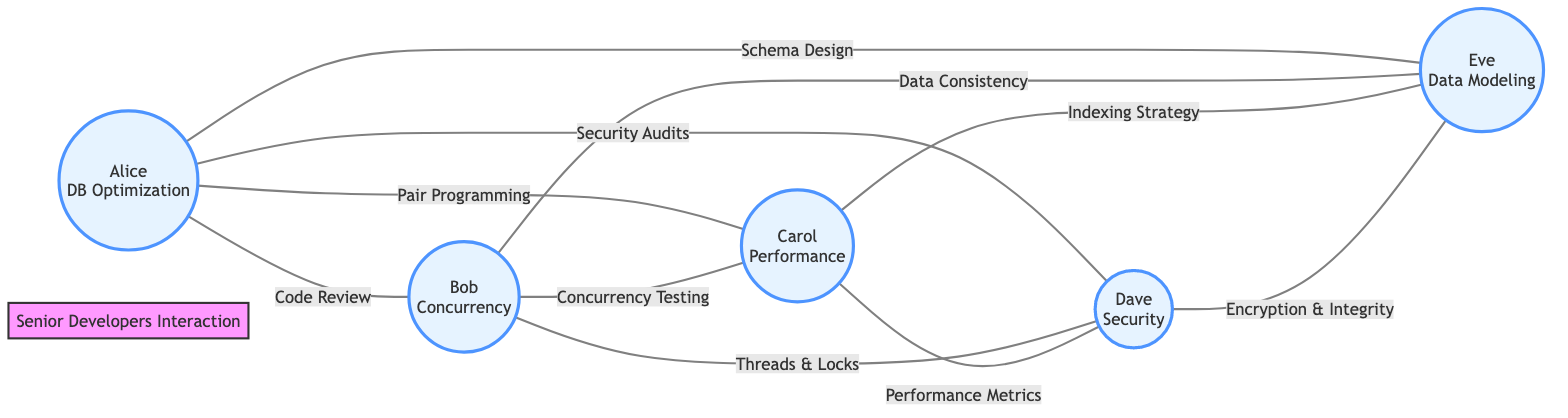What are the specialties of the developers in the diagram? The developers are specialized in Database Optimization, Concurrency, Performance Tuning, Security, and Data Modeling, as indicated in their node descriptions.
Answer: Database Optimization, Concurrency, Performance Tuning, Security, Data Modeling Who did Alice have a Code Review interaction with? The edge labeled "Code Review" from Alice points to Bob, indicating that Alice interacts with Bob regarding Code Review.
Answer: Bob How many total interactions are illustrated in the graph? Counting the edges, there are ten interactions represented in the diagram, corresponding to the specific edges listed between each pair of developers.
Answer: 10 Which developer is involved in the Encryption and Data Integrity interaction? The interaction "Encryption and Data Integrity" connects Dave and Eve, showing that Dave discusses this topic with Eve.
Answer: Eve Which pair of developers collaborates on the Indexing Strategy? From the edge labeled "Indexing Strategy," it's clear that Carol works with Eve on this collaboration.
Answer: Carol and Eve What is the relationship between Bob and Carol? The interaction labeled "Concurrency Testing" indicates there is a direct relationship between Bob and Carol, centering on their joint discussion of concurrency issues.
Answer: Concurrency Testing Which developer interacts with the most other developers? By reviewing the edges, Alice interacts with four other developers (Bob, Carol, Dave, Eve), making her the one with the most interactions.
Answer: Alice What type of interaction is not present in the graph? Looking through the edges, there are no "Bug Fixing" interactions depicted in the diagram, suggesting it is omitted from the existing collaboration types.
Answer: Bug Fixing Which interaction connects the specialties of Performance Tuning and Security? The edge labeled "Performance Metrics Analysis" connects Carol's specialty (Performance Tuning) with Dave's specialty (Security), showing their collaborative focus.
Answer: Performance Metrics Analysis 